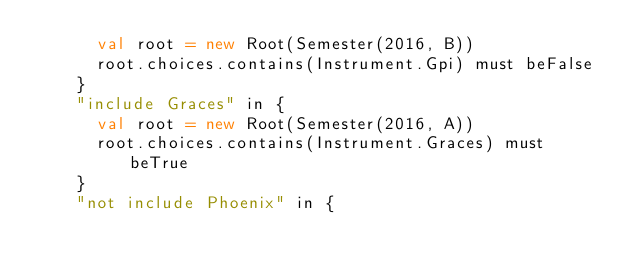Convert code to text. <code><loc_0><loc_0><loc_500><loc_500><_Scala_>      val root = new Root(Semester(2016, B))
      root.choices.contains(Instrument.Gpi) must beFalse
    }
    "include Graces" in {
      val root = new Root(Semester(2016, A))
      root.choices.contains(Instrument.Graces) must beTrue
    }
    "not include Phoenix" in {</code> 